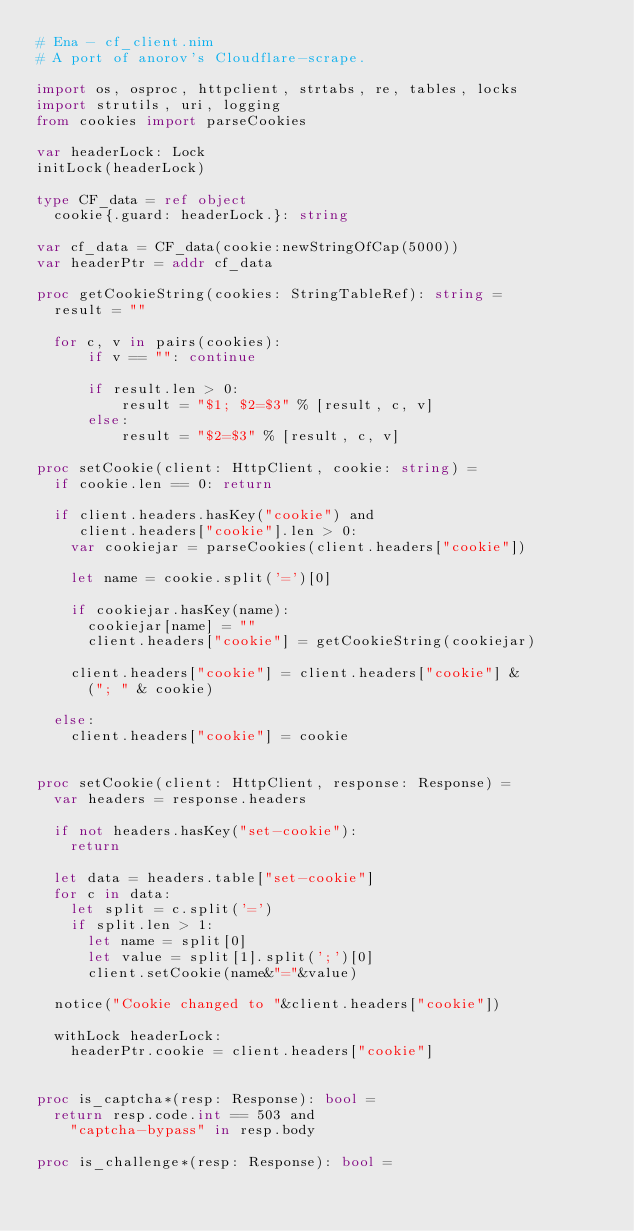<code> <loc_0><loc_0><loc_500><loc_500><_Nim_># Ena - cf_client.nim
# A port of anorov's Cloudflare-scrape.

import os, osproc, httpclient, strtabs, re, tables, locks
import strutils, uri, logging
from cookies import parseCookies

var headerLock: Lock
initLock(headerLock)

type CF_data = ref object
  cookie{.guard: headerLock.}: string

var cf_data = CF_data(cookie:newStringOfCap(5000))
var headerPtr = addr cf_data

proc getCookieString(cookies: StringTableRef): string =
  result = ""

  for c, v in pairs(cookies):
      if v == "": continue
  
      if result.len > 0:
          result = "$1; $2=$3" % [result, c, v]
      else:
          result = "$2=$3" % [result, c, v]

proc setCookie(client: HttpClient, cookie: string) =
  if cookie.len == 0: return

  if client.headers.hasKey("cookie") and 
     client.headers["cookie"].len > 0:
    var cookiejar = parseCookies(client.headers["cookie"])

    let name = cookie.split('=')[0]

    if cookiejar.hasKey(name):
      cookiejar[name] = ""
      client.headers["cookie"] = getCookieString(cookiejar)

    client.headers["cookie"] = client.headers["cookie"] &
      ("; " & cookie)

  else:
    client.headers["cookie"] = cookie


proc setCookie(client: HttpClient, response: Response) =
  var headers = response.headers
  
  if not headers.hasKey("set-cookie"):
    return
  
  let data = headers.table["set-cookie"]
  for c in data:
    let split = c.split('=')
    if split.len > 1:
      let name = split[0]
      let value = split[1].split(';')[0]
      client.setCookie(name&"="&value)
  
  notice("Cookie changed to "&client.headers["cookie"])
  
  withLock headerLock:
    headerPtr.cookie = client.headers["cookie"]


proc is_captcha*(resp: Response): bool =
  return resp.code.int == 503 and 
    "captcha-bypass" in resp.body

proc is_challenge*(resp: Response): bool =</code> 